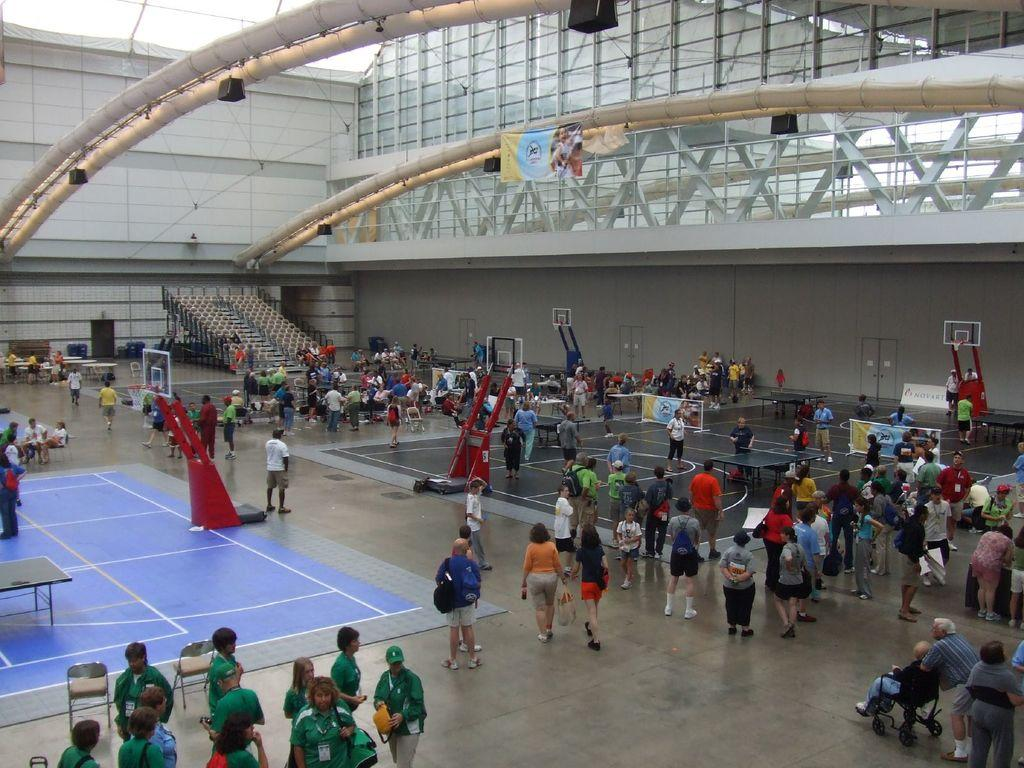What characters are featured in the image? There are two Batman figures in the image. How many carts are present in the image? There are ten carts in the image. What are the people in the image doing? Some people are playing, while others are standing and watching. What type of cases can be seen in the image? There are star cases in the image. What type of vacation is being taken by the Batman figures in the image? There is no indication of a vacation in the image; it simply features Batman figures, carts, and people playing or watching. How many breaths can be counted in the image? Breathing is not visible in the image, so it is not possible to count breaths. 